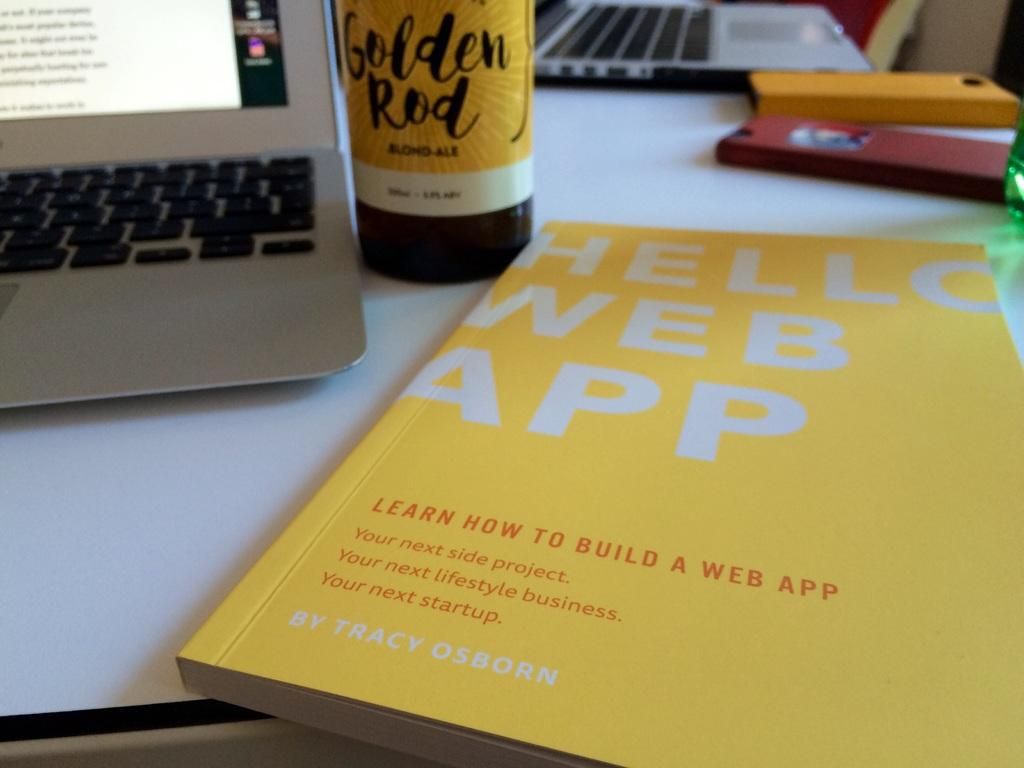<image>
Present a compact description of the photo's key features. A yellow book titled Hello Web App sits on a white table. 